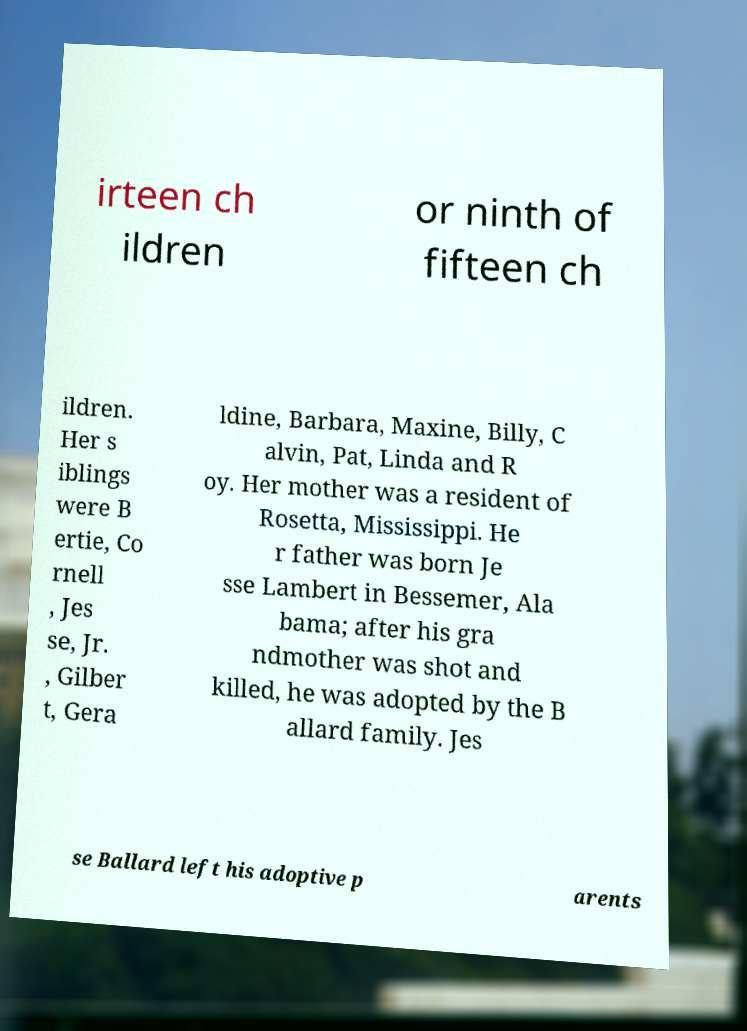Can you accurately transcribe the text from the provided image for me? irteen ch ildren or ninth of fifteen ch ildren. Her s iblings were B ertie, Co rnell , Jes se, Jr. , Gilber t, Gera ldine, Barbara, Maxine, Billy, C alvin, Pat, Linda and R oy. Her mother was a resident of Rosetta, Mississippi. He r father was born Je sse Lambert in Bessemer, Ala bama; after his gra ndmother was shot and killed, he was adopted by the B allard family. Jes se Ballard left his adoptive p arents 